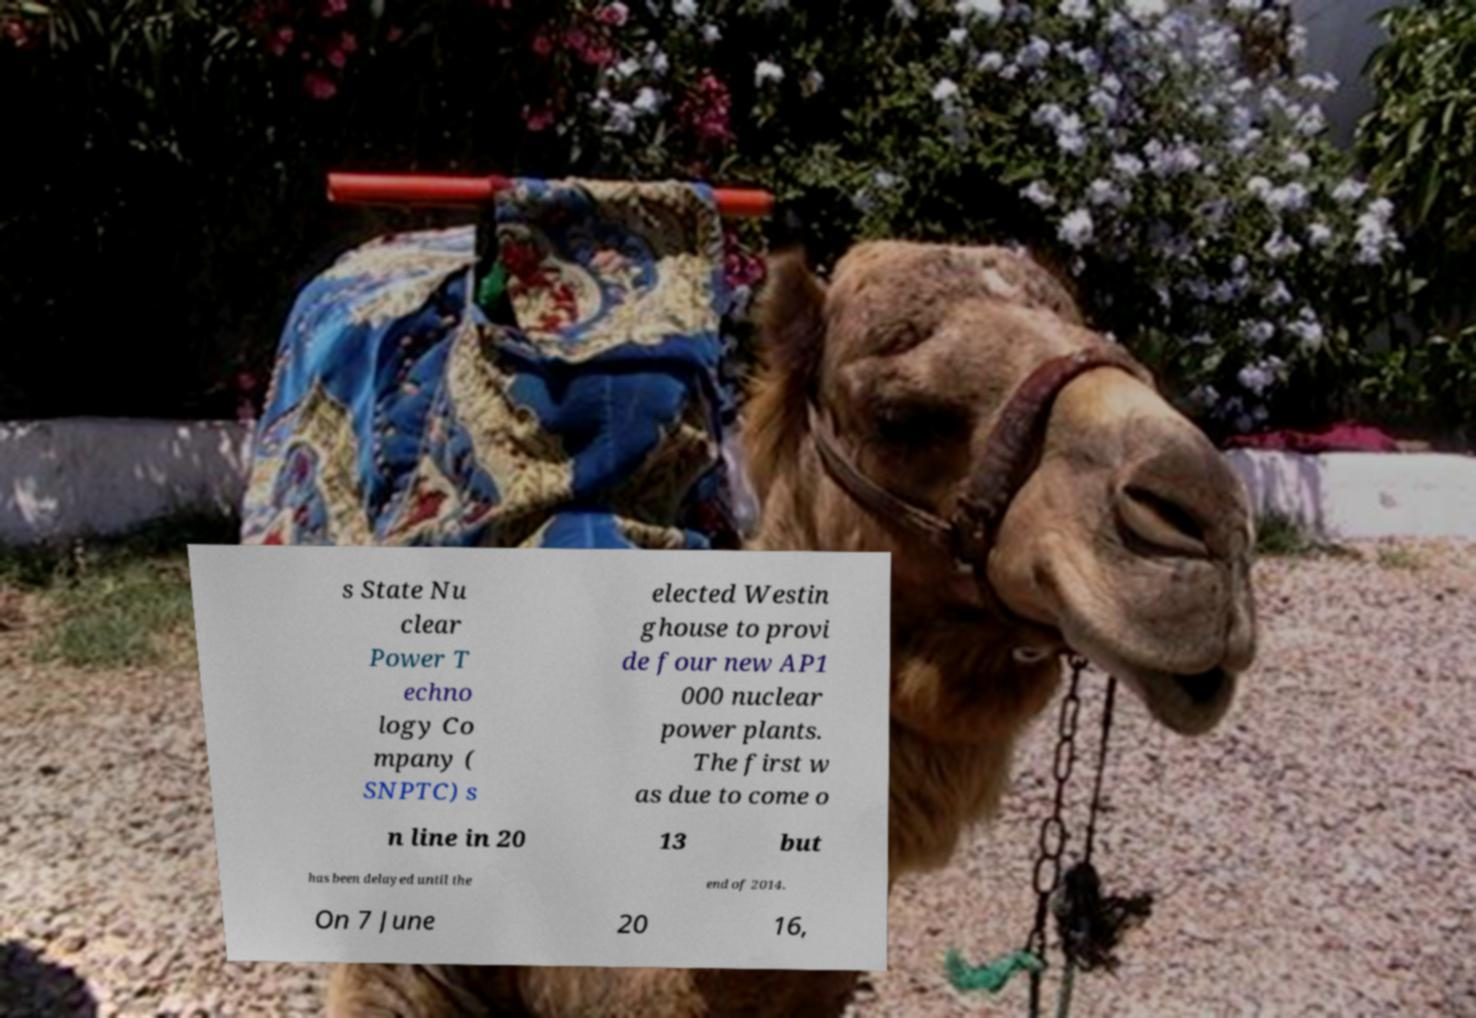Please identify and transcribe the text found in this image. s State Nu clear Power T echno logy Co mpany ( SNPTC) s elected Westin ghouse to provi de four new AP1 000 nuclear power plants. The first w as due to come o n line in 20 13 but has been delayed until the end of 2014. On 7 June 20 16, 